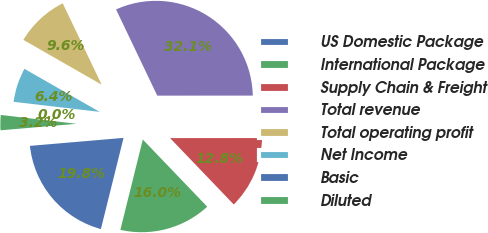<chart> <loc_0><loc_0><loc_500><loc_500><pie_chart><fcel>US Domestic Package<fcel>International Package<fcel>Supply Chain & Freight<fcel>Total revenue<fcel>Total operating profit<fcel>Net Income<fcel>Basic<fcel>Diluted<nl><fcel>19.77%<fcel>16.04%<fcel>12.84%<fcel>32.09%<fcel>9.63%<fcel>6.42%<fcel>0.0%<fcel>3.21%<nl></chart> 